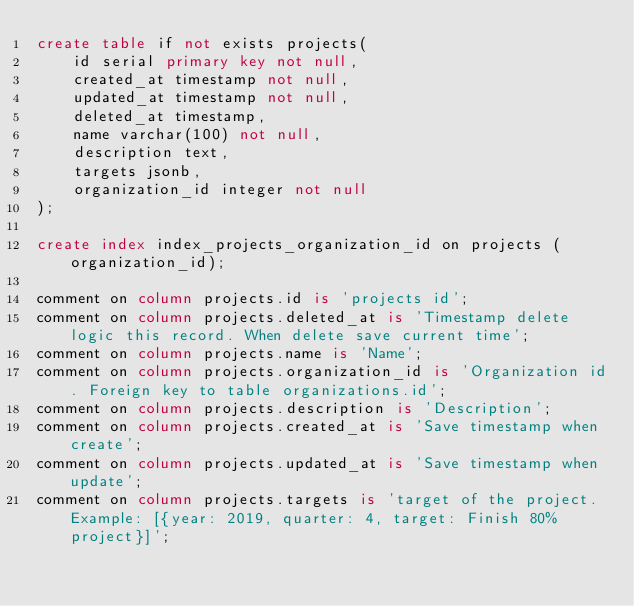Convert code to text. <code><loc_0><loc_0><loc_500><loc_500><_SQL_>create table if not exists projects(
    id serial primary key not null,
    created_at timestamp not null,
    updated_at timestamp not null,
    deleted_at timestamp,
    name varchar(100) not null,
    description text,
    targets jsonb,
    organization_id integer not null
);

create index index_projects_organization_id on projects (organization_id);

comment on column projects.id is 'projects id';
comment on column projects.deleted_at is 'Timestamp delete logic this record. When delete save current time';
comment on column projects.name is 'Name';
comment on column projects.organization_id is 'Organization id. Foreign key to table organizations.id';
comment on column projects.description is 'Description';
comment on column projects.created_at is 'Save timestamp when create';
comment on column projects.updated_at is 'Save timestamp when update';
comment on column projects.targets is 'target of the project. Example: [{year: 2019, quarter: 4, target: Finish 80% project}]';
</code> 